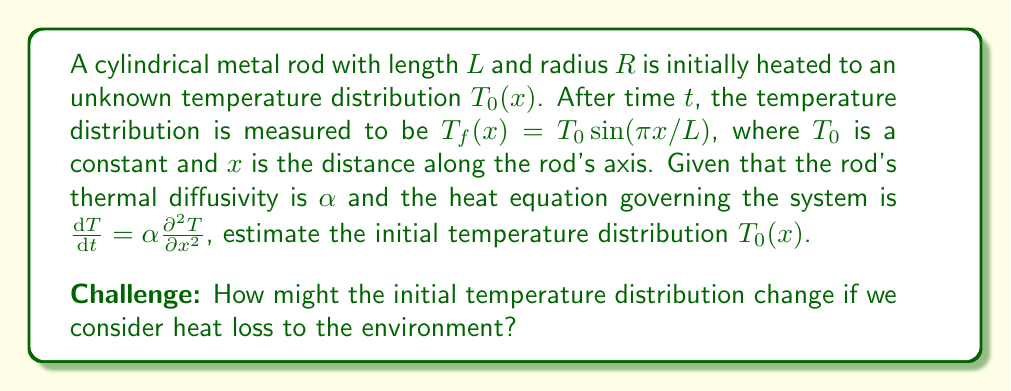Provide a solution to this math problem. To solve this inverse problem, we'll follow these steps:

1) The general solution to the heat equation for a rod of length $L$ with insulated ends is:

   $$T(x,t) = \sum_{n=1}^{\infty} A_n \sin(\frac{n\pi x}{L}) e^{-\alpha(\frac{n\pi}{L})^2 t}$$

2) We're given the final state $T_f(x) = T_0 \sin(\pi x/L)$, which matches the first term of the series (n=1). This suggests that the initial state was also of this form, but with a different amplitude.

3) Let's assume the initial state was $T_0(x) = A \sin(\pi x/L)$, where $A$ is unknown.

4) Substituting into the general solution:

   $$T_0 \sin(\frac{\pi x}{L}) = A \sin(\frac{\pi x}{L}) e^{-\alpha(\frac{\pi}{L})^2 t}$$

5) The amplitudes must be equal, so:

   $$T_0 = A e^{-\alpha(\frac{\pi}{L})^2 t}$$

6) Solving for $A$:

   $$A = T_0 e^{\alpha(\frac{\pi}{L})^2 t}$$

7) Therefore, the estimated initial temperature distribution is:

   $$T_0(x) = T_0 e^{\alpha(\frac{\pi}{L})^2 t} \sin(\frac{\pi x}{L})$$

For the challenge: If we consider heat loss to the environment, we would need to modify the heat equation to include a term for Newton's law of cooling. This would change the eigenfunctions of the problem and potentially lead to a more complex initial temperature distribution estimate.
Answer: $T_0(x) = T_0 e^{\alpha(\frac{\pi}{L})^2 t} \sin(\frac{\pi x}{L})$ 